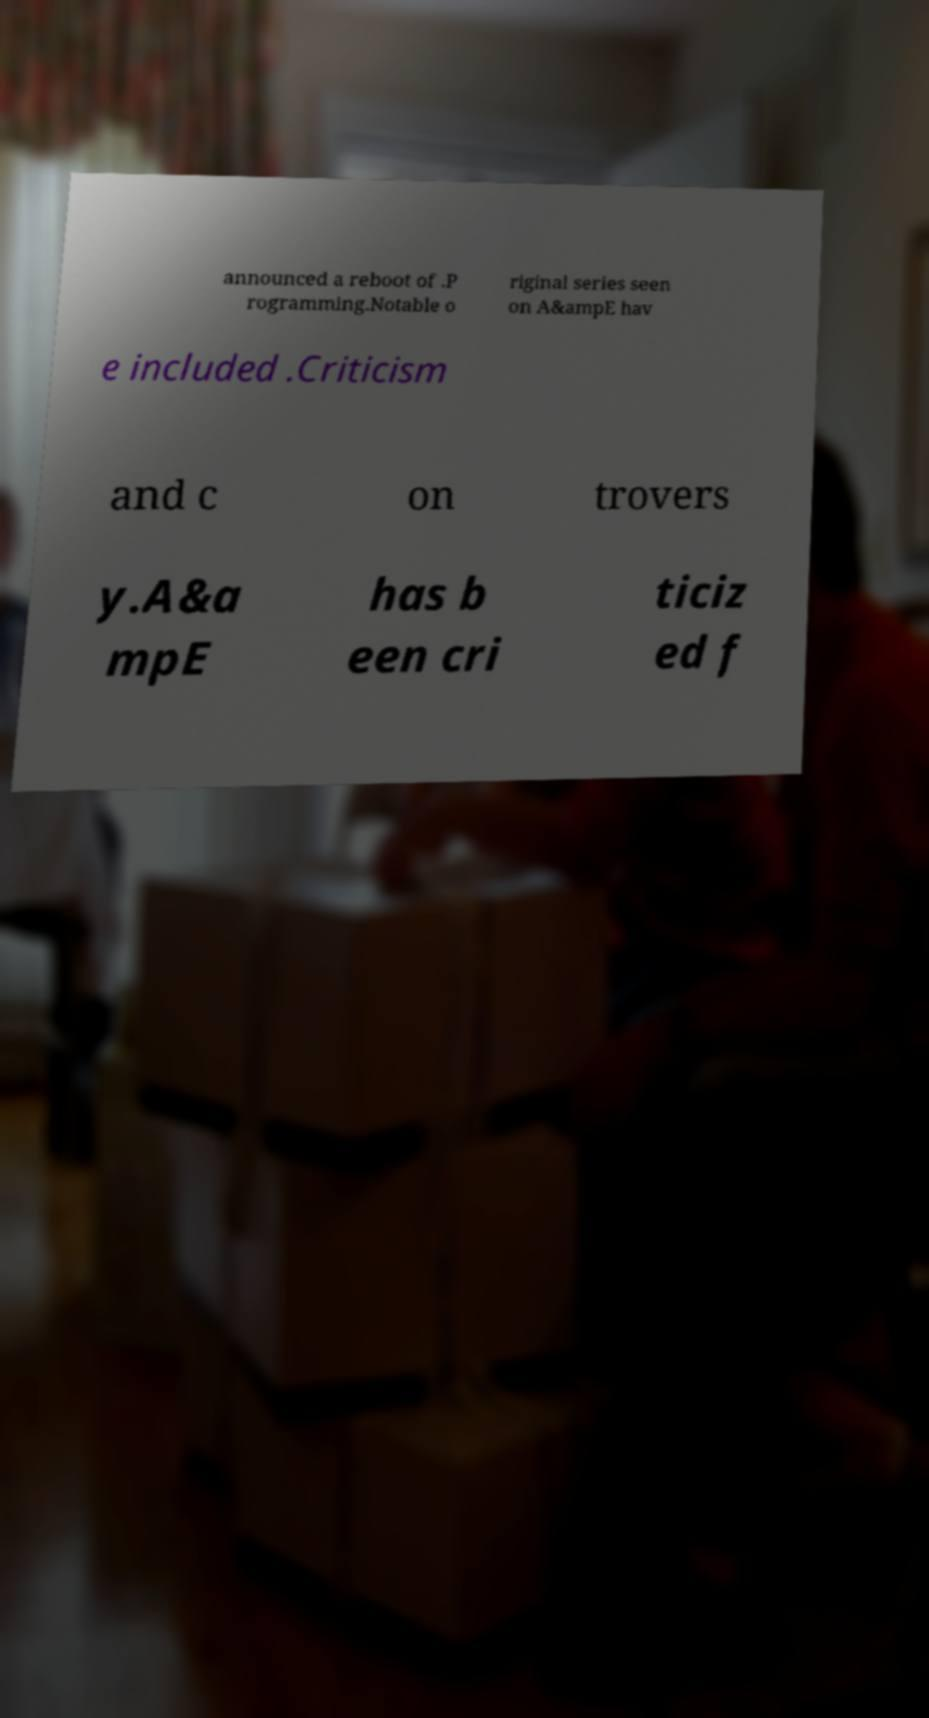I need the written content from this picture converted into text. Can you do that? announced a reboot of .P rogramming.Notable o riginal series seen on A&ampE hav e included .Criticism and c on trovers y.A&a mpE has b een cri ticiz ed f 